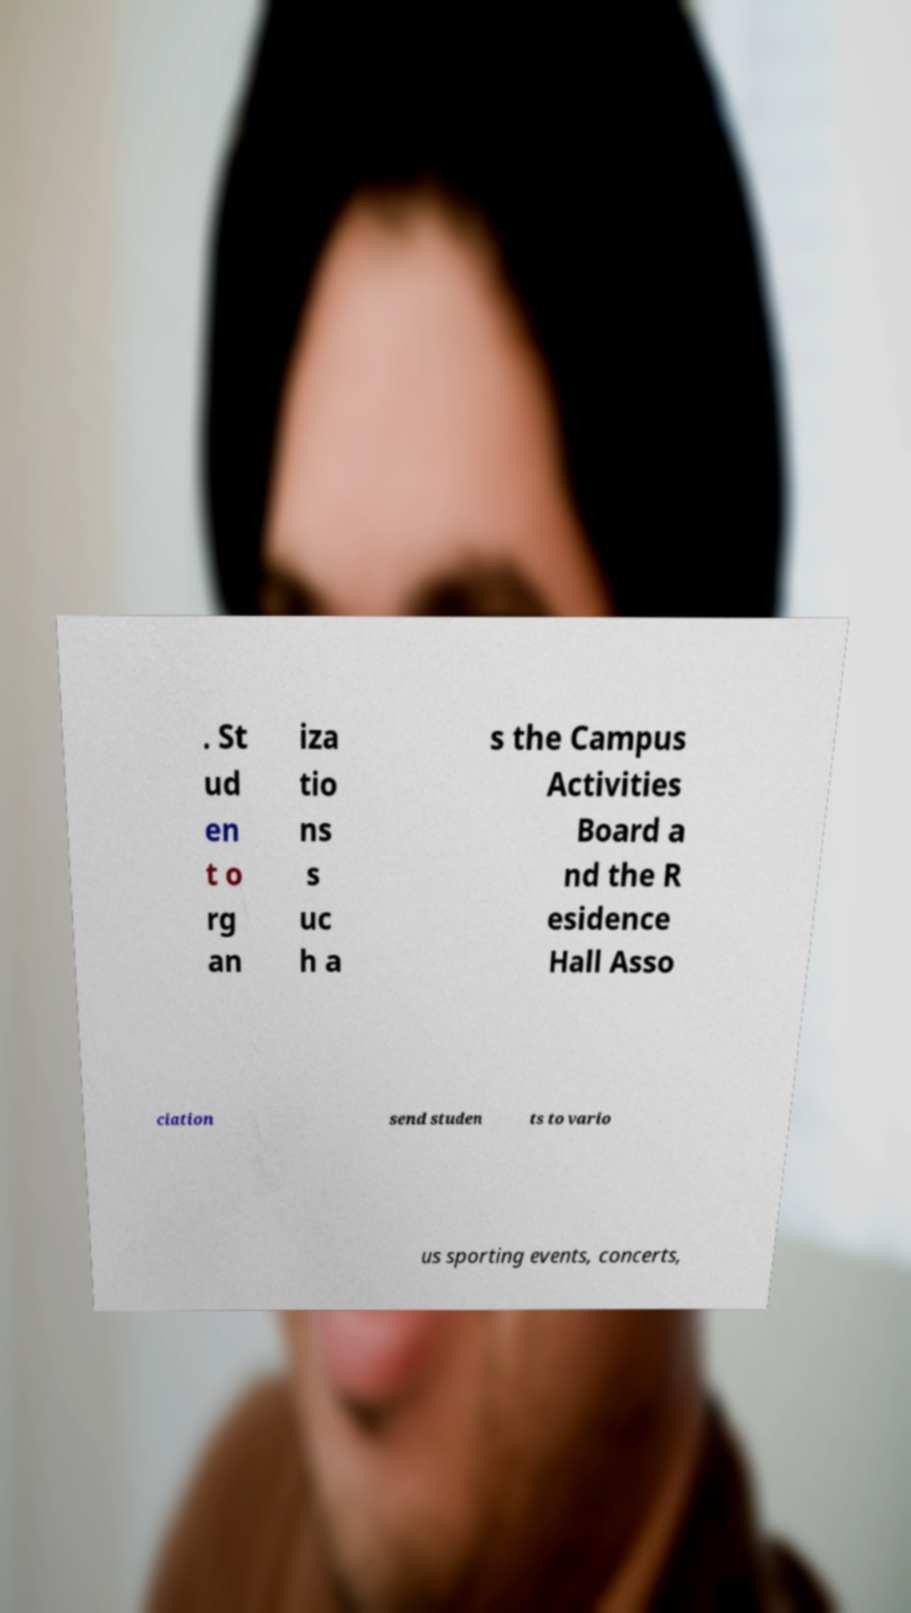Could you assist in decoding the text presented in this image and type it out clearly? . St ud en t o rg an iza tio ns s uc h a s the Campus Activities Board a nd the R esidence Hall Asso ciation send studen ts to vario us sporting events, concerts, 